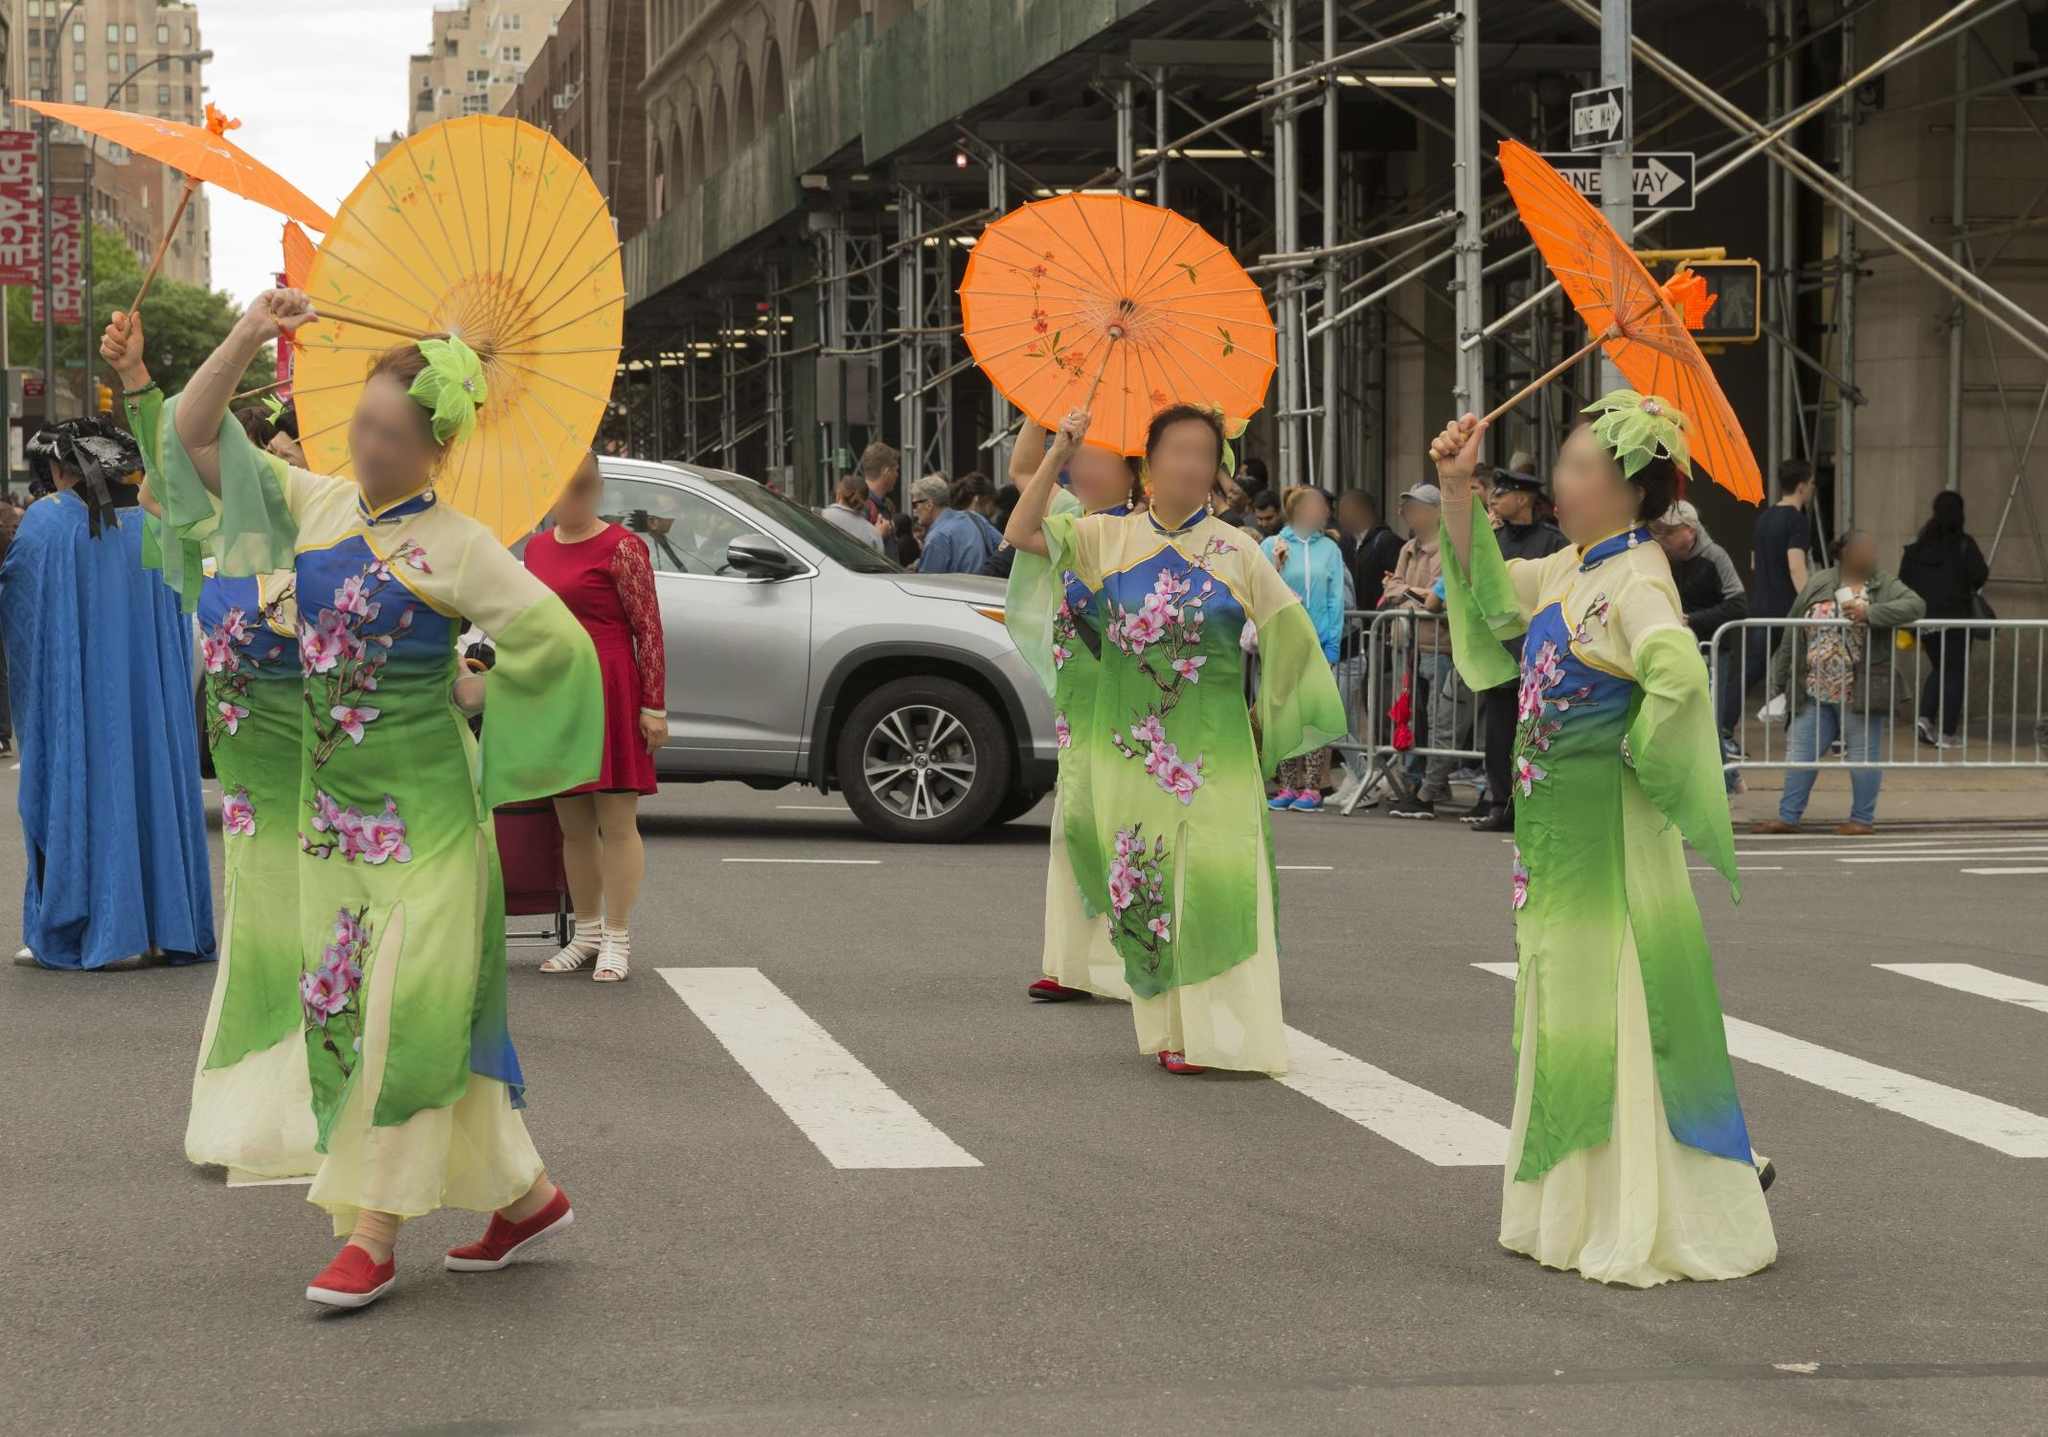If this scene were from a story, what might be happening? Give a creative narrative. In a bustling modern city where ancient traditions merge seamlessly with contemporary life, four guardian spirits of the seasons have descended to bless the town. Clad in green kimonos symbolizing the renewal of spring, these ethereal beings walk with grace, their parasols shimmering like magical shields against the worries of the world. As they move through the streets, the flowers on their attire seem to come alive, blooming with every step. The city, once grey and mundane, transforms into a garden of vibrant life, where every resident feels the touch of nature's harmony and the promise of renewal. This parade is not just a festive event, but a mystical ceremony where the boundaries between the spiritual and the earthly blur, leaving behind an enchanting aura of hope and unity. 